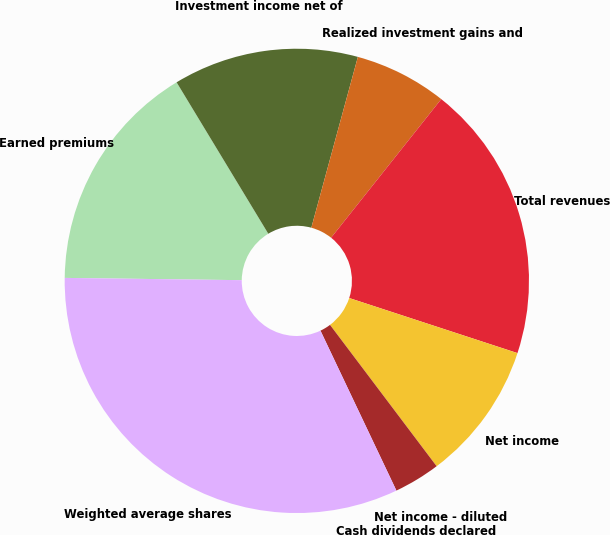Convert chart to OTSL. <chart><loc_0><loc_0><loc_500><loc_500><pie_chart><fcel>Earned premiums<fcel>Investment income net of<fcel>Realized investment gains and<fcel>Total revenues<fcel>Net income<fcel>Net income - diluted<fcel>Cash dividends declared<fcel>Weighted average shares<nl><fcel>16.13%<fcel>12.9%<fcel>6.45%<fcel>19.35%<fcel>9.68%<fcel>3.23%<fcel>0.0%<fcel>32.26%<nl></chart> 